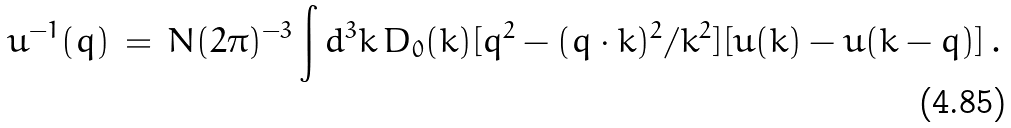Convert formula to latex. <formula><loc_0><loc_0><loc_500><loc_500>u ^ { - 1 } ( q ) \, = \, N ( 2 \pi ) ^ { - 3 } \int d ^ { 3 } k \, D _ { 0 } ( k ) [ q ^ { 2 } - ( q \cdot k ) ^ { 2 } / k ^ { 2 } ] [ u ( k ) - u ( k - q ) ] \, .</formula> 